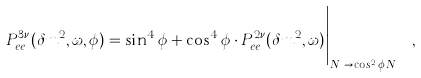<formula> <loc_0><loc_0><loc_500><loc_500>P _ { e e } ^ { 3 \nu } ( \delta m ^ { 2 } , \omega , \phi ) = \sin ^ { 4 } \phi + \cos ^ { 4 } \phi \cdot P _ { e e } ^ { 2 \nu } ( \delta m ^ { 2 } , \omega ) \Big | _ { N _ { e } \to \cos ^ { 2 } \phi \, N _ { e } } \ ,</formula> 